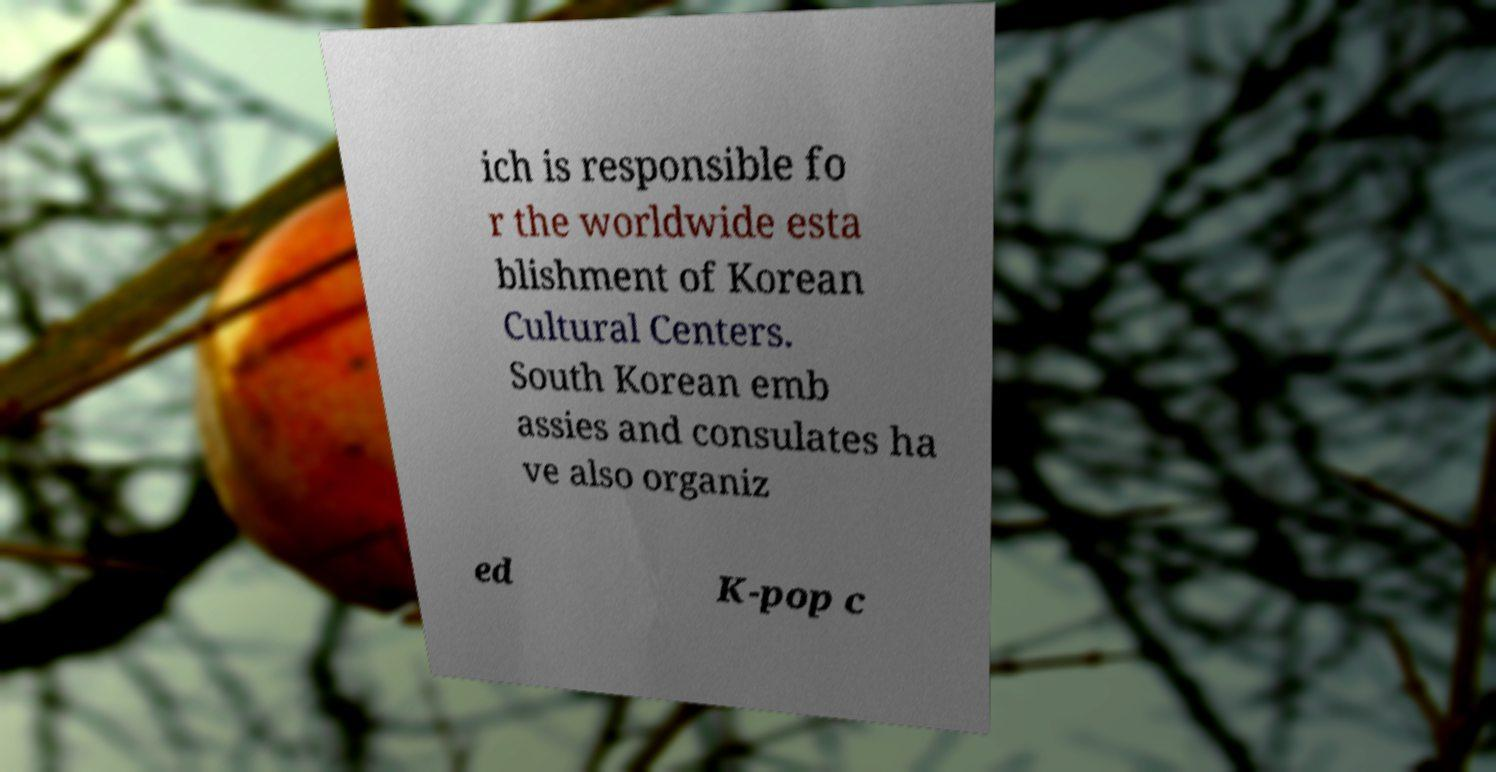Could you assist in decoding the text presented in this image and type it out clearly? ich is responsible fo r the worldwide esta blishment of Korean Cultural Centers. South Korean emb assies and consulates ha ve also organiz ed K-pop c 